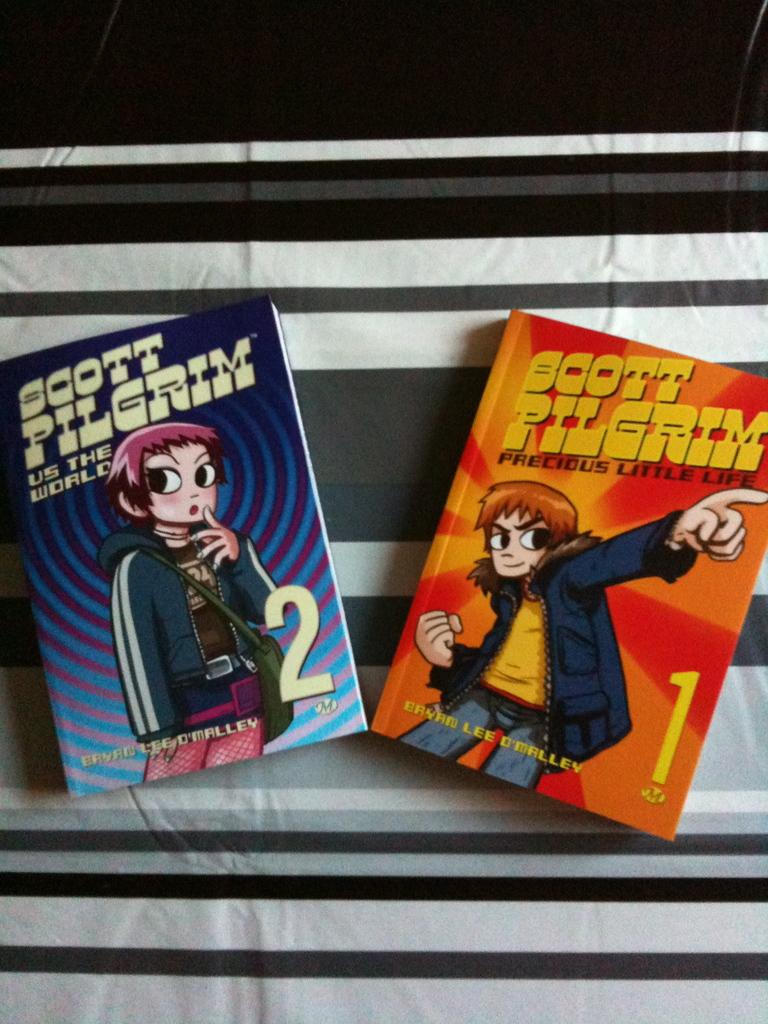<image>
Present a compact description of the photo's key features. Two books with the title Scott Pilgrim on them. 